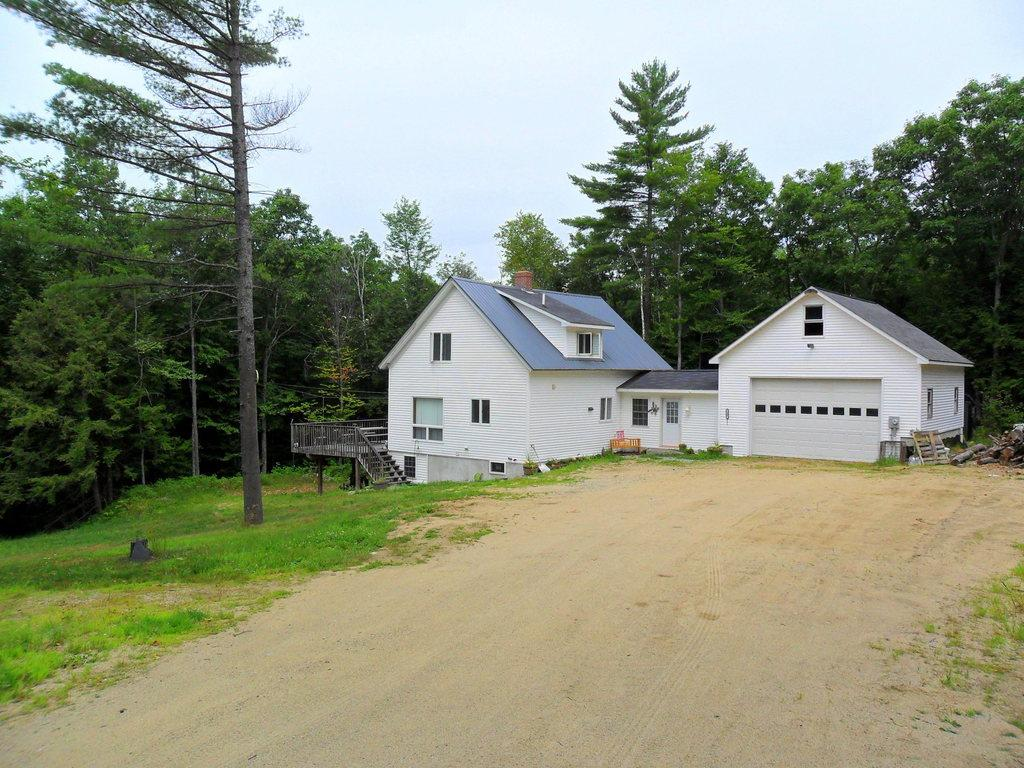What can be seen in the foreground of the image? There is a path and grass in the foreground of the image. What is located in the background of the image? There is a house, stairs, trees, and the sky visible in the background of the image. Can you describe the path in the foreground? The path is visible in the foreground, but no specific details about its appearance or condition are provided. What type of impulse can be seen affecting the trees in the background of the image? There is no indication of any impulse affecting the trees in the image; they appear to be standing still. What time is displayed on the clock in the image? There is no clock present in the image. 